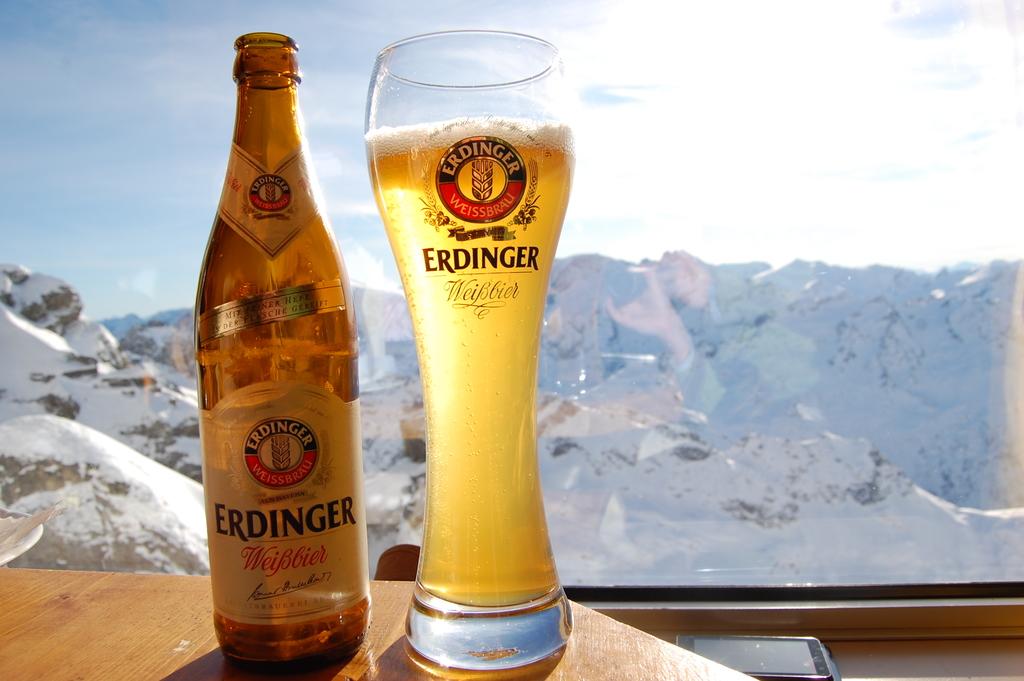What's the name of this beer?
Provide a succinct answer. Erdinger. 